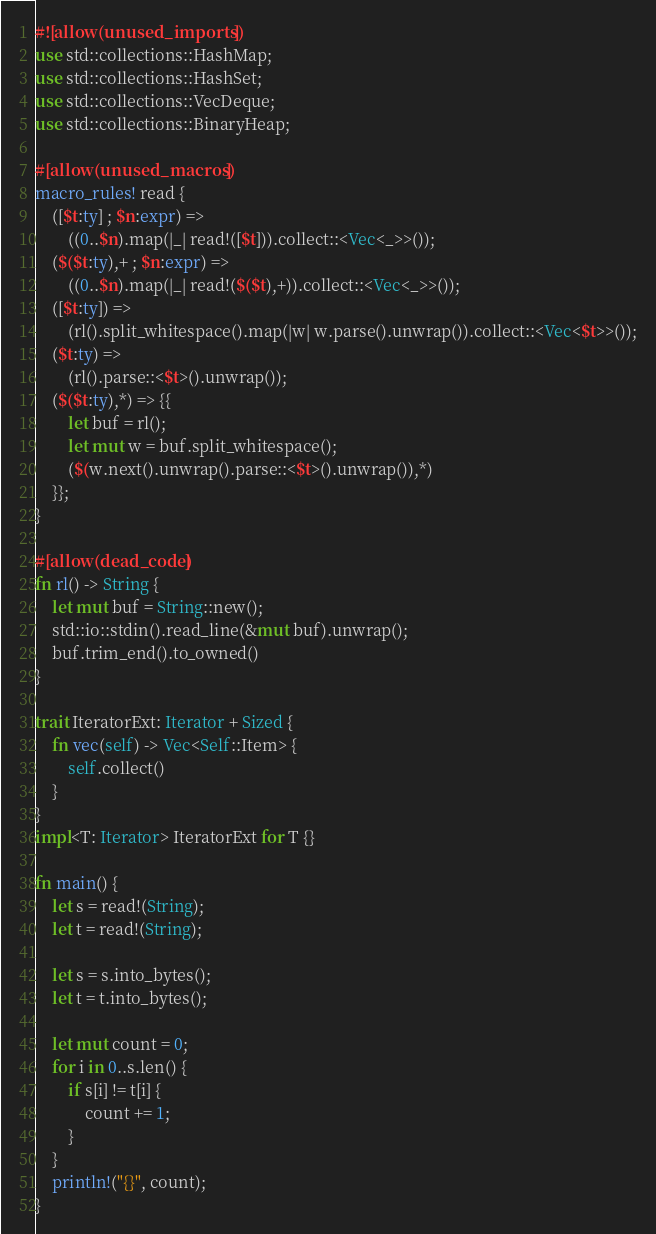Convert code to text. <code><loc_0><loc_0><loc_500><loc_500><_Rust_>#![allow(unused_imports)]
use std::collections::HashMap;
use std::collections::HashSet;
use std::collections::VecDeque;
use std::collections::BinaryHeap;

#[allow(unused_macros)]
macro_rules! read {
    ([$t:ty] ; $n:expr) =>
        ((0..$n).map(|_| read!([$t])).collect::<Vec<_>>());
    ($($t:ty),+ ; $n:expr) =>
        ((0..$n).map(|_| read!($($t),+)).collect::<Vec<_>>());
    ([$t:ty]) =>
        (rl().split_whitespace().map(|w| w.parse().unwrap()).collect::<Vec<$t>>());
    ($t:ty) =>
        (rl().parse::<$t>().unwrap());
    ($($t:ty),*) => {{
        let buf = rl();
        let mut w = buf.split_whitespace();
        ($(w.next().unwrap().parse::<$t>().unwrap()),*)
    }};
}

#[allow(dead_code)]
fn rl() -> String {
    let mut buf = String::new();
    std::io::stdin().read_line(&mut buf).unwrap();
    buf.trim_end().to_owned()
}

trait IteratorExt: Iterator + Sized {
    fn vec(self) -> Vec<Self::Item> {
        self.collect()
    }
}
impl<T: Iterator> IteratorExt for T {}

fn main() {
    let s = read!(String);
    let t = read!(String);

    let s = s.into_bytes();
    let t = t.into_bytes();

    let mut count = 0;
    for i in 0..s.len() {
        if s[i] != t[i] {
            count += 1;
        }
    }
    println!("{}", count);
}</code> 